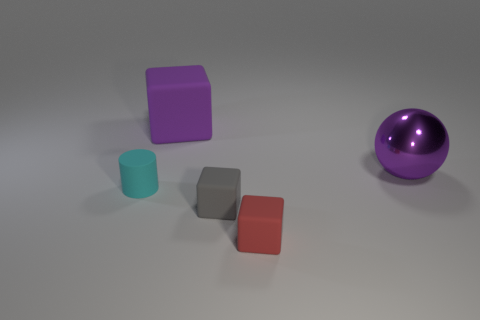How many other things are the same color as the cylinder?
Your answer should be compact. 0. What is the shape of the object that is the same size as the purple cube?
Your answer should be very brief. Sphere. How many large things are either purple metallic spheres or blue matte balls?
Give a very brief answer. 1. Is there a gray thing to the left of the tiny matte thing left of the block behind the small cylinder?
Make the answer very short. No. Are there any cyan rubber cylinders that have the same size as the metal object?
Keep it short and to the point. No. What material is the red thing that is the same size as the gray object?
Keep it short and to the point. Rubber. Do the shiny thing and the cyan thing in front of the big metal sphere have the same size?
Give a very brief answer. No. What number of matte objects are either small things or big cyan things?
Offer a very short reply. 3. How many other matte objects have the same shape as the tiny gray thing?
Your answer should be very brief. 2. There is another thing that is the same color as the metallic thing; what material is it?
Provide a succinct answer. Rubber. 